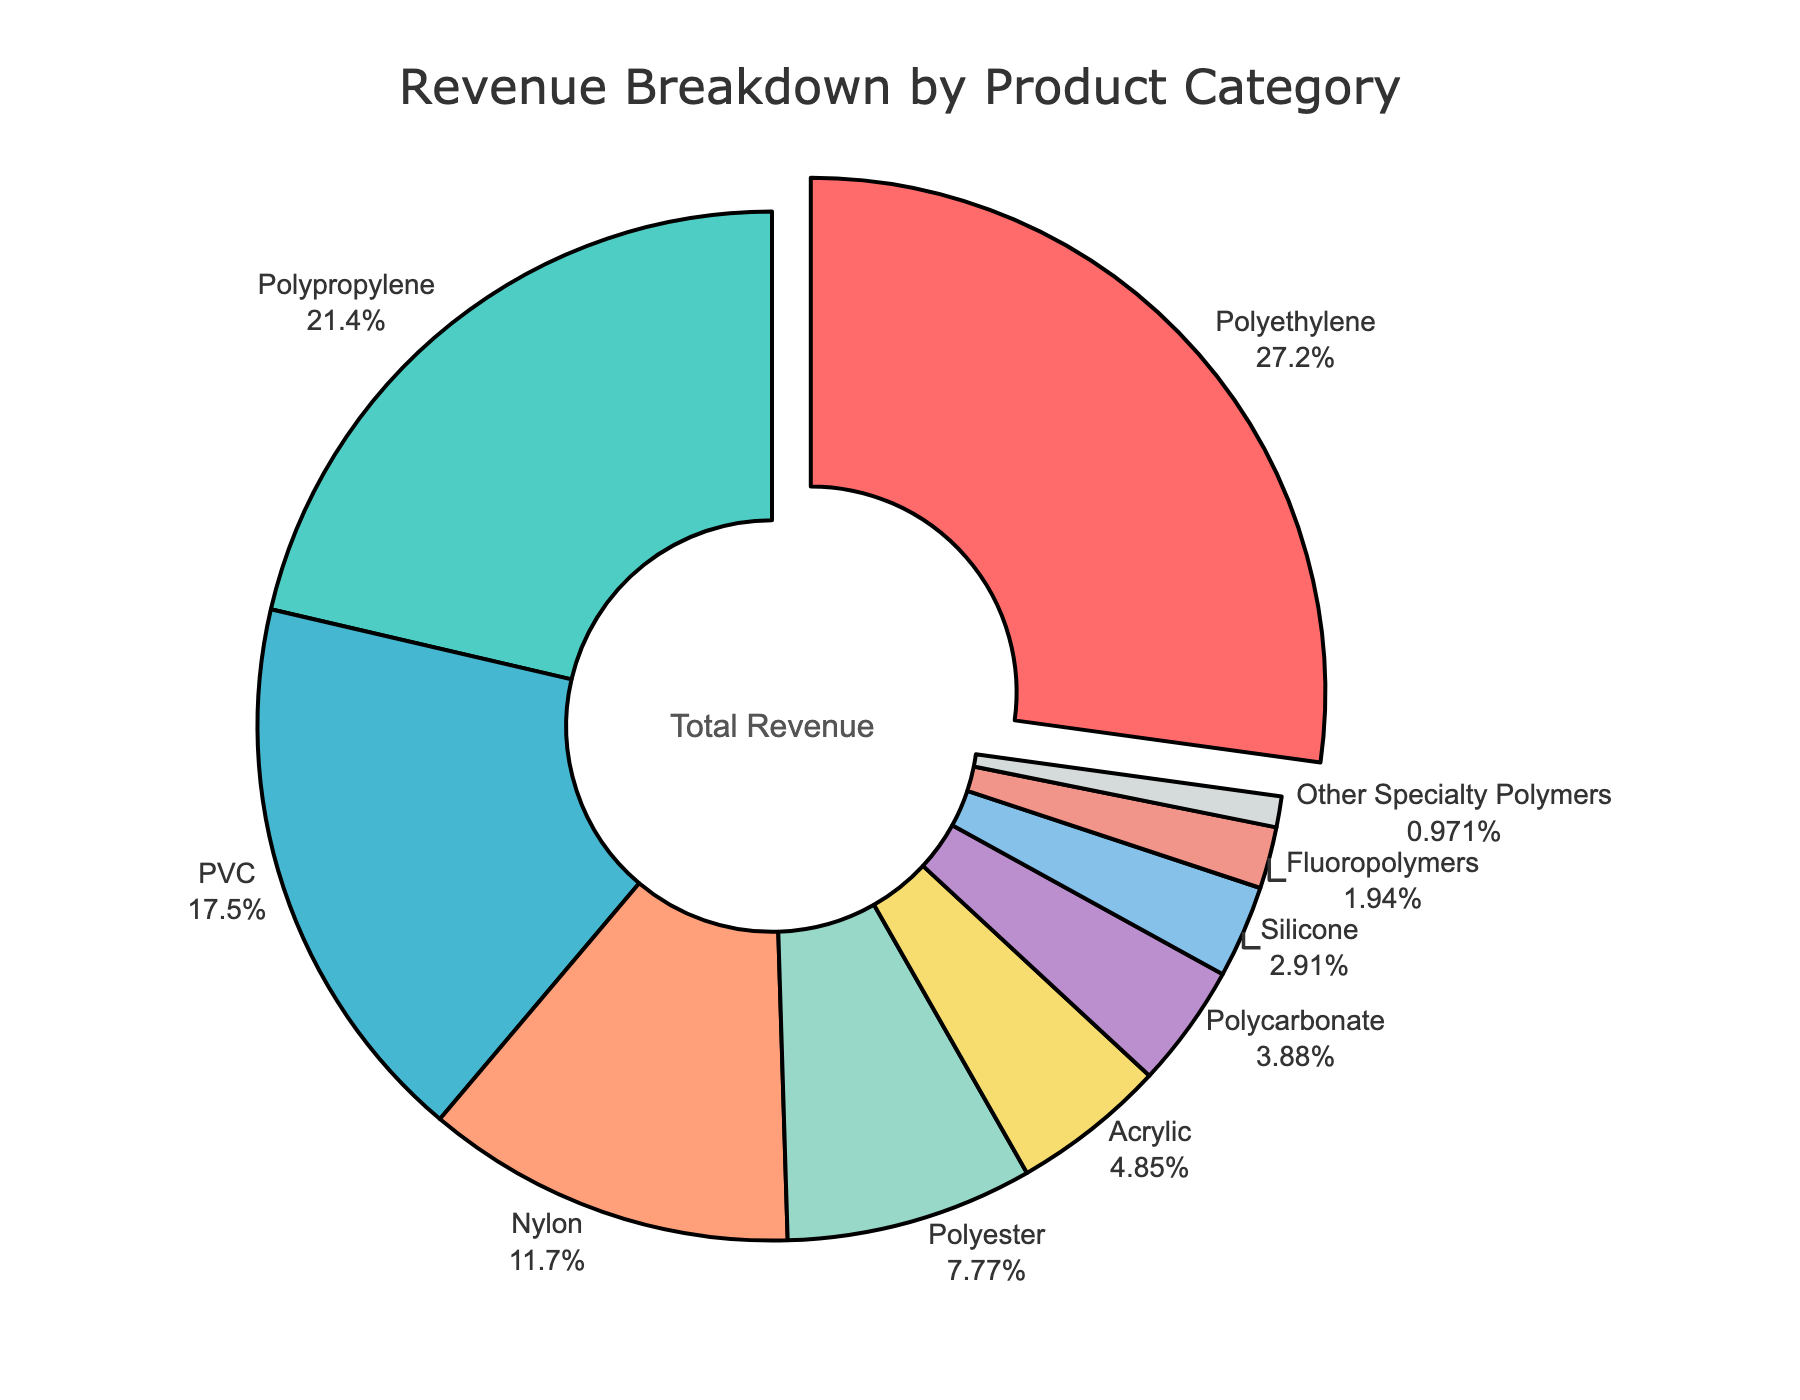What is the largest revenue source for the distributor? The pie chart highlights the product category with the highest percentage by pulling it out slightly. Based on the figure, the section labeled "Polyethylene" is pulled out, indicating it is the largest revenue source.
Answer: Polyethylene Which product category contributes the least to the revenue? The pie chart indicates the smallest segment with the label "Other Specialty Polymers" with a percentage value of 1%.
Answer: Other Specialty Polymers What percentage of the revenue is generated by Polypropylene and PVC combined? Add the revenue percentages of Polypropylene (22%) and PVC (18%): 22 + 18 = 40%.
Answer: 40% Which two product categories together make up more than 50% of the revenue? From the pie chart, the two largest categories, Polyethylene (28%) and Polypropylene (22%), together make up more than 50%: 28 + 22 = 50%.
Answer: Polyethylene and Polypropylene How does the revenue generated by Nylon compare to that generated by Polyester? Compare the percentage values of Nylon (12%) and Polyester (8%) as shown in the pie chart. Since 12% is greater than 8%, Nylon generates more revenue than Polyester.
Answer: Nylon generates more revenue than Polyester What is the combined revenue percentage of the three smallest categories? The three smallest categories are Fluoropolymers (2%), Other Specialty Polymers (1%), and Silicone (3%). Their combined percentage is 2 + 1 + 3 = 6%.
Answer: 6% Which product category generates approximately a quarter of the revenue? The pie chart shows "Polyethylene" as having the largest segment close to 28%, which is approximately a quarter of the total revenue.
Answer: Polyethylene What is the combined revenue percentage of the top four product categories? Add the percentages of the top four categories: Polyethylene (28%), Polypropylene (22%), PVC (18%), and Nylon (12%): 28 + 22 + 18 + 12 = 80%.
Answer: 80% How many product categories contribute to less than 10% each? From the pie chart, the categories contributing less than 10% are Polyester (8%), Acrylic (5%), Polycarbonate (4%), Silicone (3%), Fluoropolymers (2%), and Other Specialty Polymers (1%). This totals to 6 categories.
Answer: 6 What proportion of the revenue is generated by Acrylic compared to Polycarbonate? Compare the percentages of Acrylic (5%) and Polycarbonate (4%). To find the proportion of Acrylic to Polycarbonate: 5 / 4 = 1.25.
Answer: 1.25 